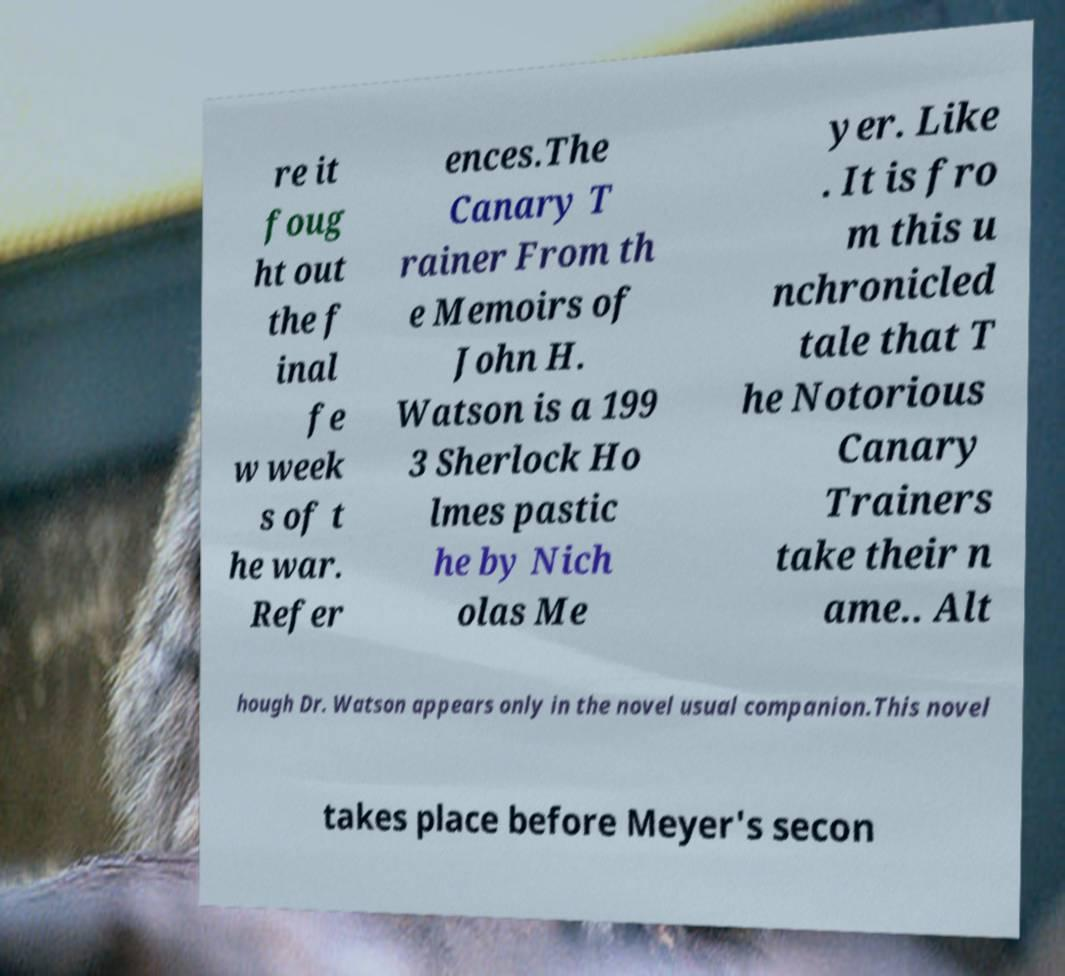There's text embedded in this image that I need extracted. Can you transcribe it verbatim? re it foug ht out the f inal fe w week s of t he war. Refer ences.The Canary T rainer From th e Memoirs of John H. Watson is a 199 3 Sherlock Ho lmes pastic he by Nich olas Me yer. Like . It is fro m this u nchronicled tale that T he Notorious Canary Trainers take their n ame.. Alt hough Dr. Watson appears only in the novel usual companion.This novel takes place before Meyer's secon 